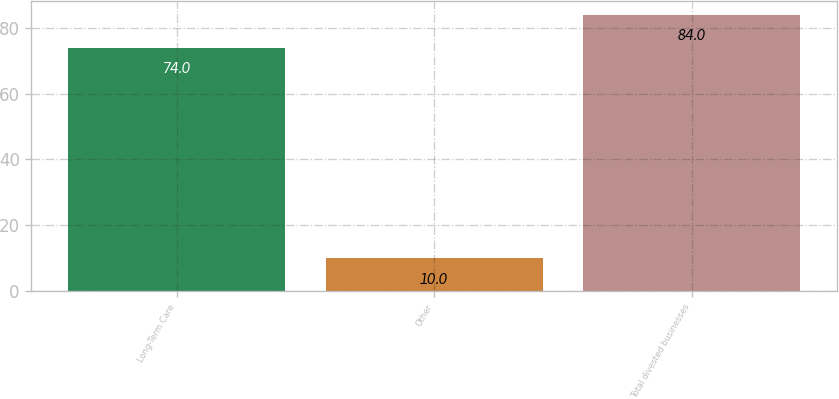Convert chart. <chart><loc_0><loc_0><loc_500><loc_500><bar_chart><fcel>Long-Term Care<fcel>Other<fcel>Total divested businesses<nl><fcel>74<fcel>10<fcel>84<nl></chart> 